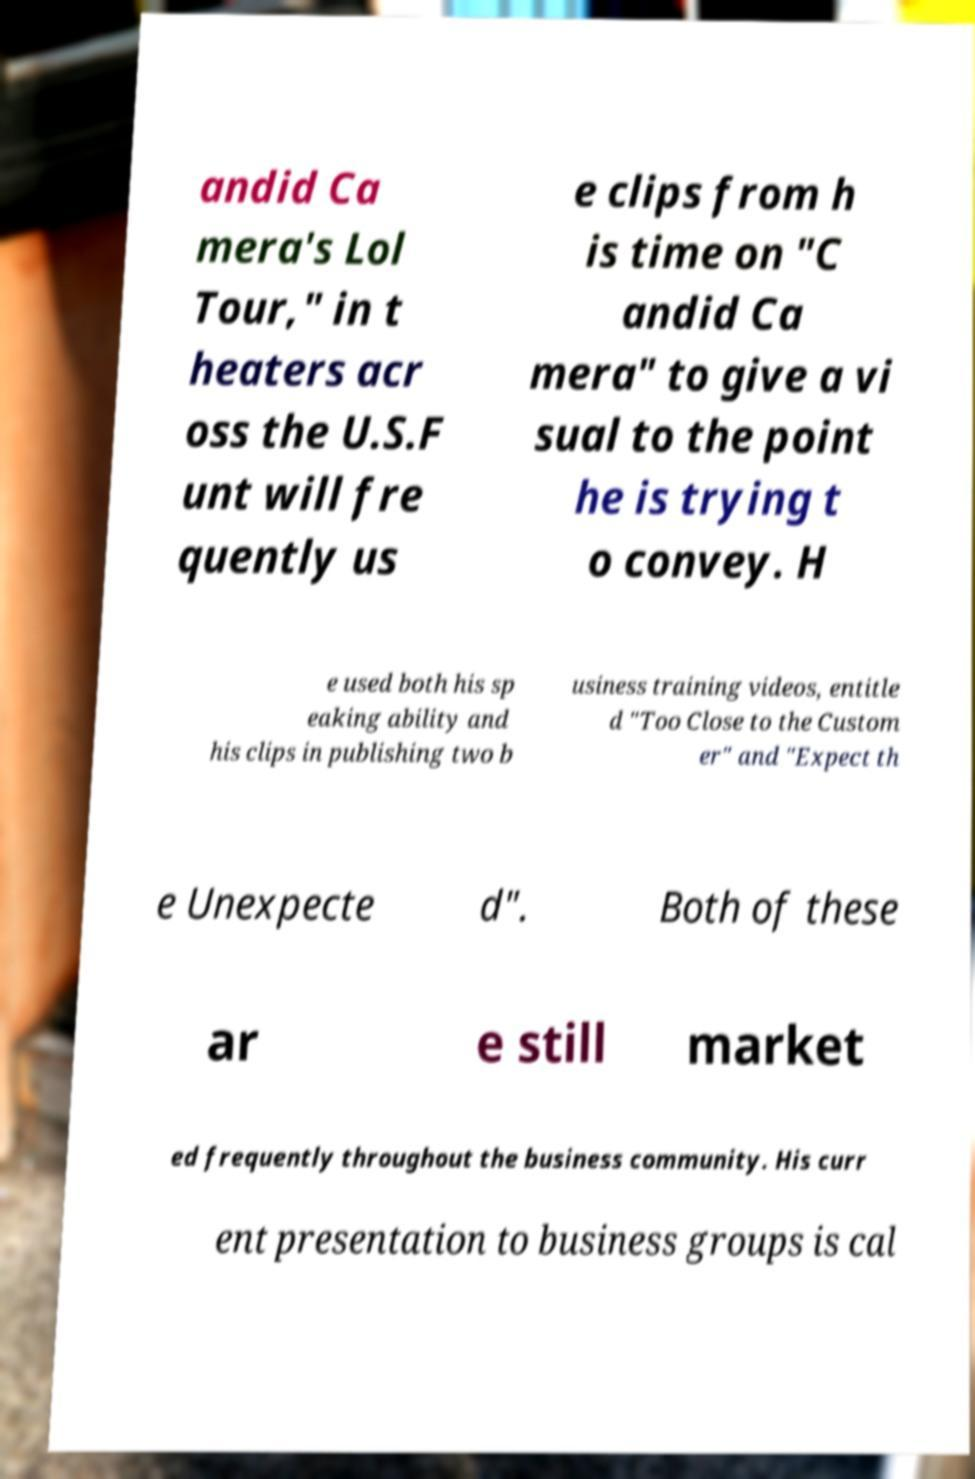Can you accurately transcribe the text from the provided image for me? andid Ca mera's Lol Tour," in t heaters acr oss the U.S.F unt will fre quently us e clips from h is time on "C andid Ca mera" to give a vi sual to the point he is trying t o convey. H e used both his sp eaking ability and his clips in publishing two b usiness training videos, entitle d "Too Close to the Custom er" and "Expect th e Unexpecte d". Both of these ar e still market ed frequently throughout the business community. His curr ent presentation to business groups is cal 